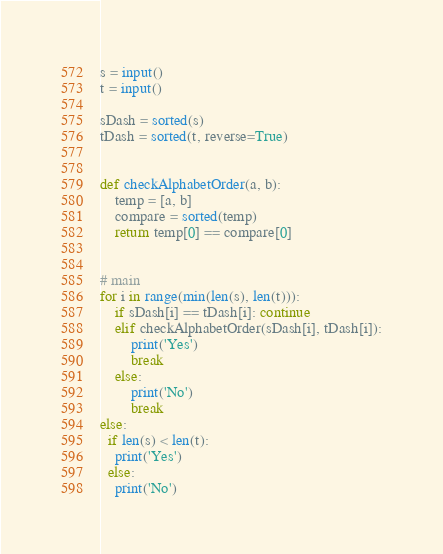Convert code to text. <code><loc_0><loc_0><loc_500><loc_500><_Python_>s = input()
t = input()

sDash = sorted(s)
tDash = sorted(t, reverse=True)


def checkAlphabetOrder(a, b):
    temp = [a, b]
    compare = sorted(temp)
    return temp[0] == compare[0]


# main
for i in range(min(len(s), len(t))):
    if sDash[i] == tDash[i]: continue
    elif checkAlphabetOrder(sDash[i], tDash[i]):
        print('Yes')
        break
    else:
        print('No')
        break
else:
  if len(s) < len(t):
    print('Yes')
  else:
    print('No')</code> 